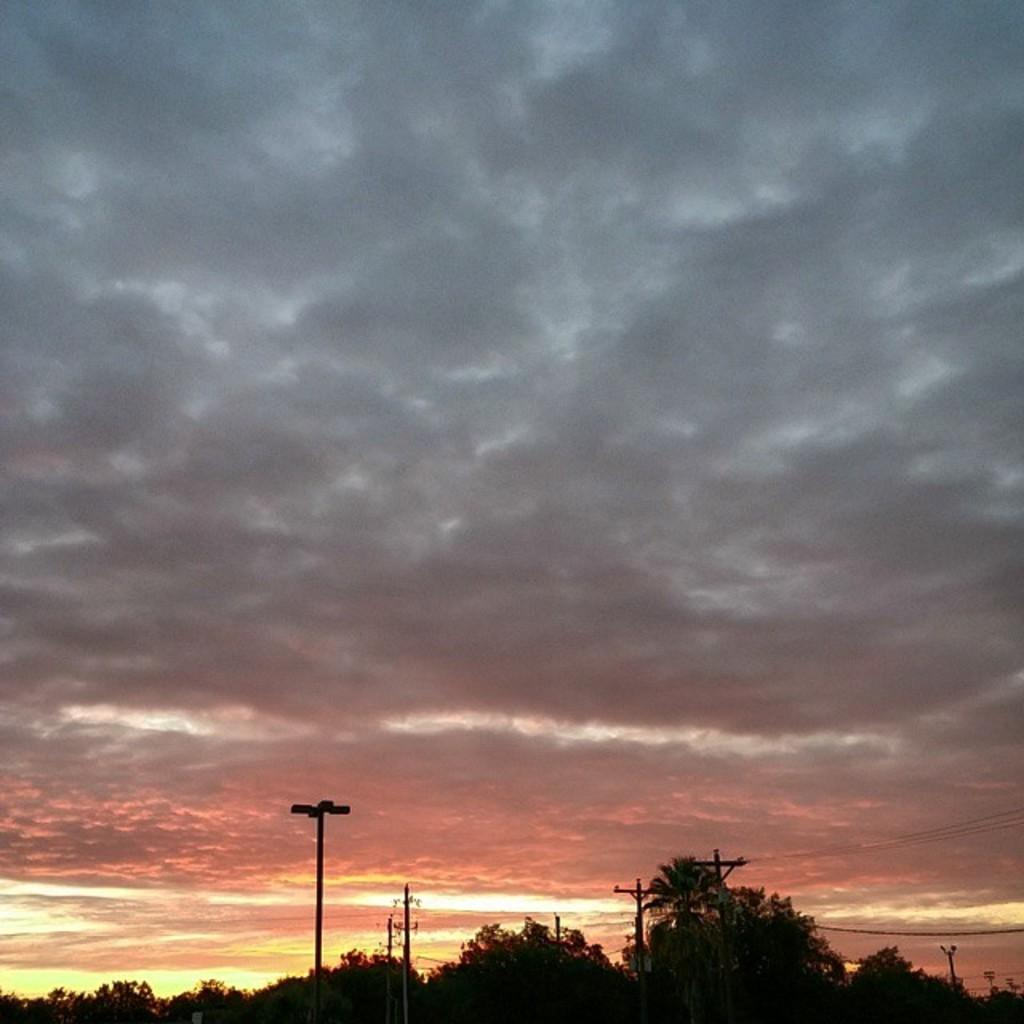What can be seen in the sky in the image? There are clouds in the sky in the image. What type of vegetation is at the bottom of the image? There are trees at the bottom of the image. What structures are visible in the image? Current poles are visible in the image. What type of bulb is hanging from the tree in the image? There is no bulb hanging from the tree in the image; it only features clouds, trees, and current poles. What scent can be detected from the image? There is no information about a scent in the image, as it only contains visual elements. 